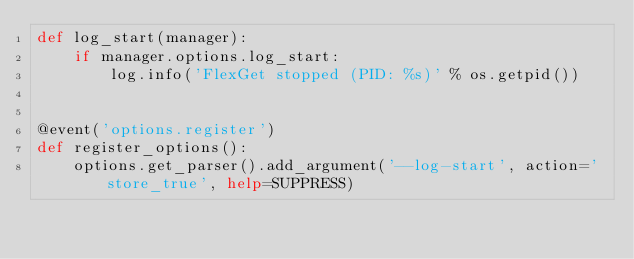Convert code to text. <code><loc_0><loc_0><loc_500><loc_500><_Python_>def log_start(manager):
    if manager.options.log_start:
        log.info('FlexGet stopped (PID: %s)' % os.getpid())


@event('options.register')
def register_options():
    options.get_parser().add_argument('--log-start', action='store_true', help=SUPPRESS)
</code> 